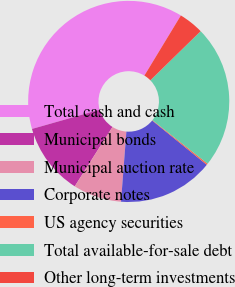Convert chart to OTSL. <chart><loc_0><loc_0><loc_500><loc_500><pie_chart><fcel>Total cash and cash<fcel>Municipal bonds<fcel>Municipal auction rate<fcel>Corporate notes<fcel>US agency securities<fcel>Total available-for-sale debt<fcel>Other long-term investments<nl><fcel>38.09%<fcel>11.58%<fcel>7.79%<fcel>15.37%<fcel>0.22%<fcel>22.94%<fcel>4.01%<nl></chart> 